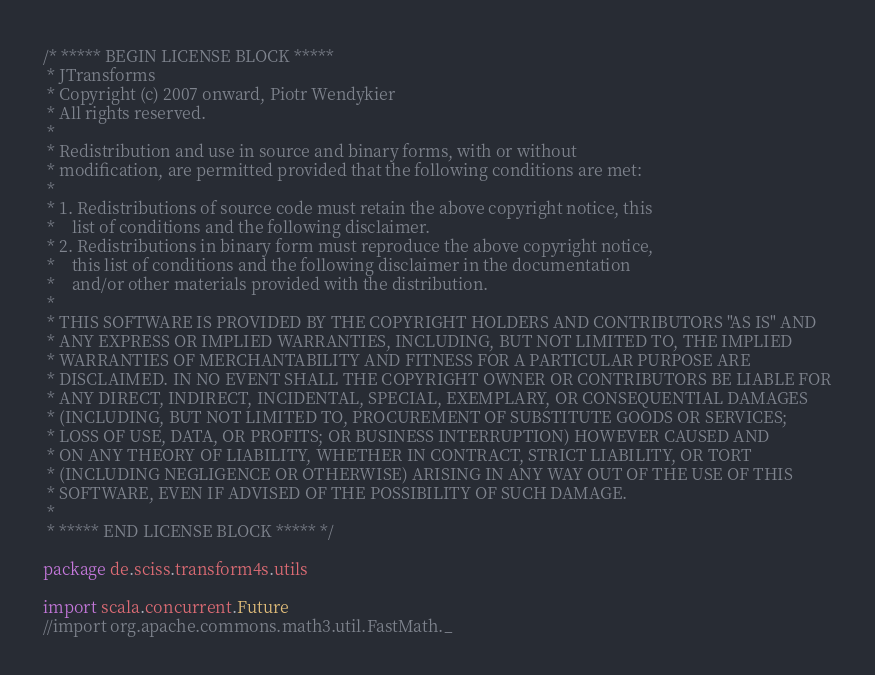<code> <loc_0><loc_0><loc_500><loc_500><_Scala_>/* ***** BEGIN LICENSE BLOCK *****
 * JTransforms
 * Copyright (c) 2007 onward, Piotr Wendykier
 * All rights reserved.
 *
 * Redistribution and use in source and binary forms, with or without
 * modification, are permitted provided that the following conditions are met:
 *
 * 1. Redistributions of source code must retain the above copyright notice, this
 *    list of conditions and the following disclaimer.
 * 2. Redistributions in binary form must reproduce the above copyright notice,
 *    this list of conditions and the following disclaimer in the documentation
 *    and/or other materials provided with the distribution.
 *
 * THIS SOFTWARE IS PROVIDED BY THE COPYRIGHT HOLDERS AND CONTRIBUTORS "AS IS" AND
 * ANY EXPRESS OR IMPLIED WARRANTIES, INCLUDING, BUT NOT LIMITED TO, THE IMPLIED
 * WARRANTIES OF MERCHANTABILITY AND FITNESS FOR A PARTICULAR PURPOSE ARE
 * DISCLAIMED. IN NO EVENT SHALL THE COPYRIGHT OWNER OR CONTRIBUTORS BE LIABLE FOR
 * ANY DIRECT, INDIRECT, INCIDENTAL, SPECIAL, EXEMPLARY, OR CONSEQUENTIAL DAMAGES
 * (INCLUDING, BUT NOT LIMITED TO, PROCUREMENT OF SUBSTITUTE GOODS OR SERVICES;
 * LOSS OF USE, DATA, OR PROFITS; OR BUSINESS INTERRUPTION) HOWEVER CAUSED AND
 * ON ANY THEORY OF LIABILITY, WHETHER IN CONTRACT, STRICT LIABILITY, OR TORT
 * (INCLUDING NEGLIGENCE OR OTHERWISE) ARISING IN ANY WAY OUT OF THE USE OF THIS
 * SOFTWARE, EVEN IF ADVISED OF THE POSSIBILITY OF SUCH DAMAGE.
 *
 * ***** END LICENSE BLOCK ***** */

package de.sciss.transform4s.utils

import scala.concurrent.Future
//import org.apache.commons.math3.util.FastMath._</code> 